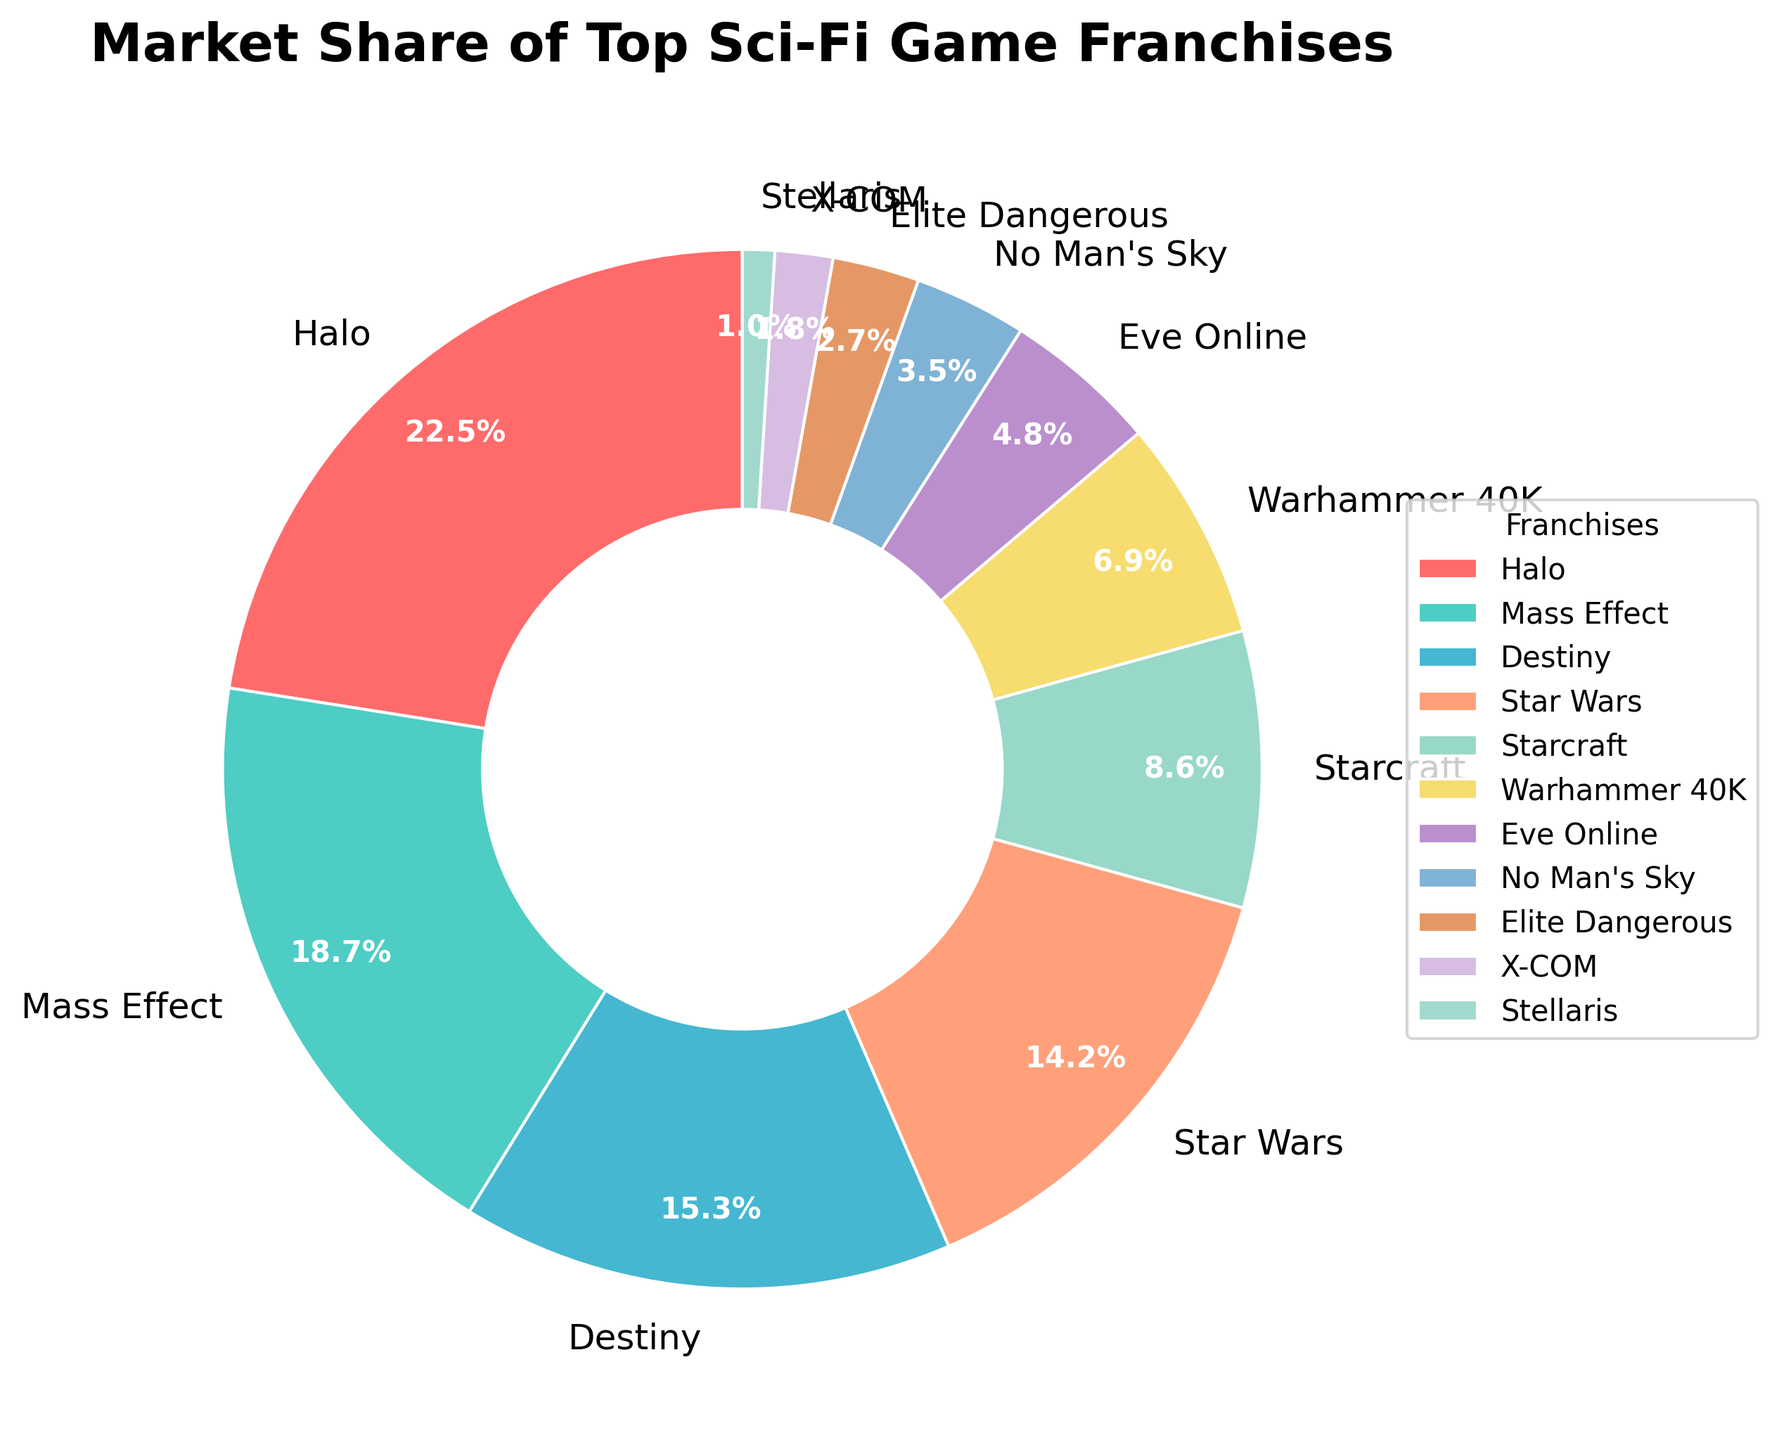Which franchise holds the largest market share? The largest segment in the pie chart belongs to the franchise with the highest percentage value. Halo has the largest segment at 22.5%.
Answer: Halo Which franchise's market share is closest to 10%? Check each segment in the pie chart and find the one whose percentage is closest to 10%. Starcraft is the closest with a market share of 8.6%.
Answer: Starcraft What is the combined market share of Halo and Mass Effect? Add the market shares of Halo and Mass Effect. Halo has 22.5% and Mass Effect has 18.7%. So, 22.5% + 18.7% = 41.2%.
Answer: 41.2% Which two franchises together have a market share less than 5%? Identify pairs of franchises where their combined market share is less than 5%. The pair "Elite Dangerous and X-COM" satisfies this condition: 2.7% + 1.8% = 4.5%.
Answer: Elite Dangerous and X-COM Which franchise has the smallest market share, and what is its color? Identify the smallest segment and its corresponding color in the pie chart. Stellaris has the smallest market share at 1.0%, and it is represented by a light blue color.
Answer: Stellaris, light blue How much more market share does Halo have compared to Destiny? Subtract the market share of Destiny from the market share of Halo. Halo has 22.5% and Destiny has 15.3%. So, 22.5% - 15.3% = 7.2%.
Answer: 7.2% Are there any franchises with equal market shares? Compare all market share values to see if any two or more are equal. In this case, no two franchises have equal market shares.
Answer: No What is the average market share of the top 5 franchises? Sum the market shares of the top 5 franchises and divide by 5. The top 5 franchises are: Halo (22.5%), Mass Effect (18.7%), Destiny (15.3%), Star Wars (14.2%), Starcraft (8.6%). (22.5 + 18.7 + 15.3 + 14.2 + 8.6) / 5 = 79.3 / 5 = 15.86%.
Answer: 15.86% Which franchise is depicted in green, and what is its market share? Identify the green segment in the pie chart and its corresponding franchise. Warhammer 40K is depicted in green and has a market share of 6.9%.
Answer: Warhammer 40K, 6.9% What is the combined market share of the franchises with the 4 smallest revenues? Add the market shares of the four smallest segments. The smallest four are Stellaris (1.0%), X-COM (1.8%), Elite Dangerous (2.7%), and No Man's Sky (3.5%). 1.0% + 1.8% + 2.7% + 3.5% = 9.0%.
Answer: 9.0% 